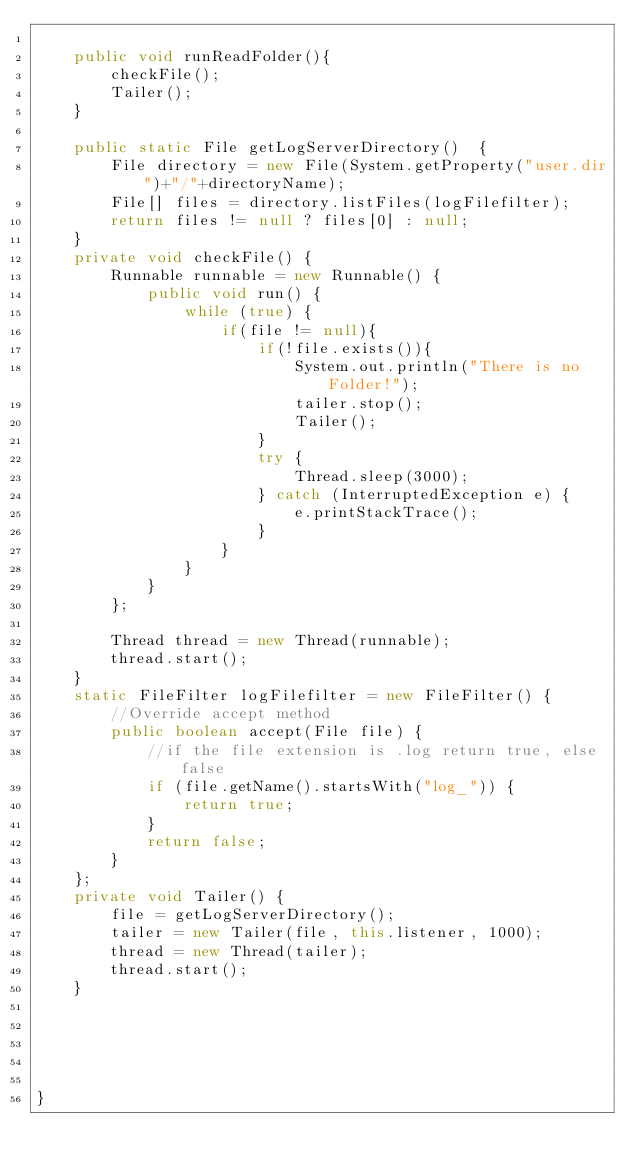Convert code to text. <code><loc_0><loc_0><loc_500><loc_500><_Java_>
    public void runReadFolder(){
        checkFile();
        Tailer();
    }

    public static File getLogServerDirectory()  {
        File directory = new File(System.getProperty("user.dir")+"/"+directoryName);
        File[] files = directory.listFiles(logFilefilter);
        return files != null ? files[0] : null;
    }
    private void checkFile() {
        Runnable runnable = new Runnable() {
            public void run() {
                while (true) {
                    if(file != null){
                        if(!file.exists()){
                            System.out.println("There is no Folder!");
                            tailer.stop();
                            Tailer();
                        }
                        try {
                            Thread.sleep(3000);
                        } catch (InterruptedException e) {
                            e.printStackTrace();
                        }
                    }
                }
            }
        };

        Thread thread = new Thread(runnable);
        thread.start();
    }
    static FileFilter logFilefilter = new FileFilter() {
        //Override accept method
        public boolean accept(File file) {
            //if the file extension is .log return true, else false
            if (file.getName().startsWith("log_")) {
                return true;
            }
            return false;
        }
    };
    private void Tailer() {
        file = getLogServerDirectory();
        tailer = new Tailer(file, this.listener, 1000);
        thread = new Thread(tailer);
        thread.start();
    }





}





</code> 